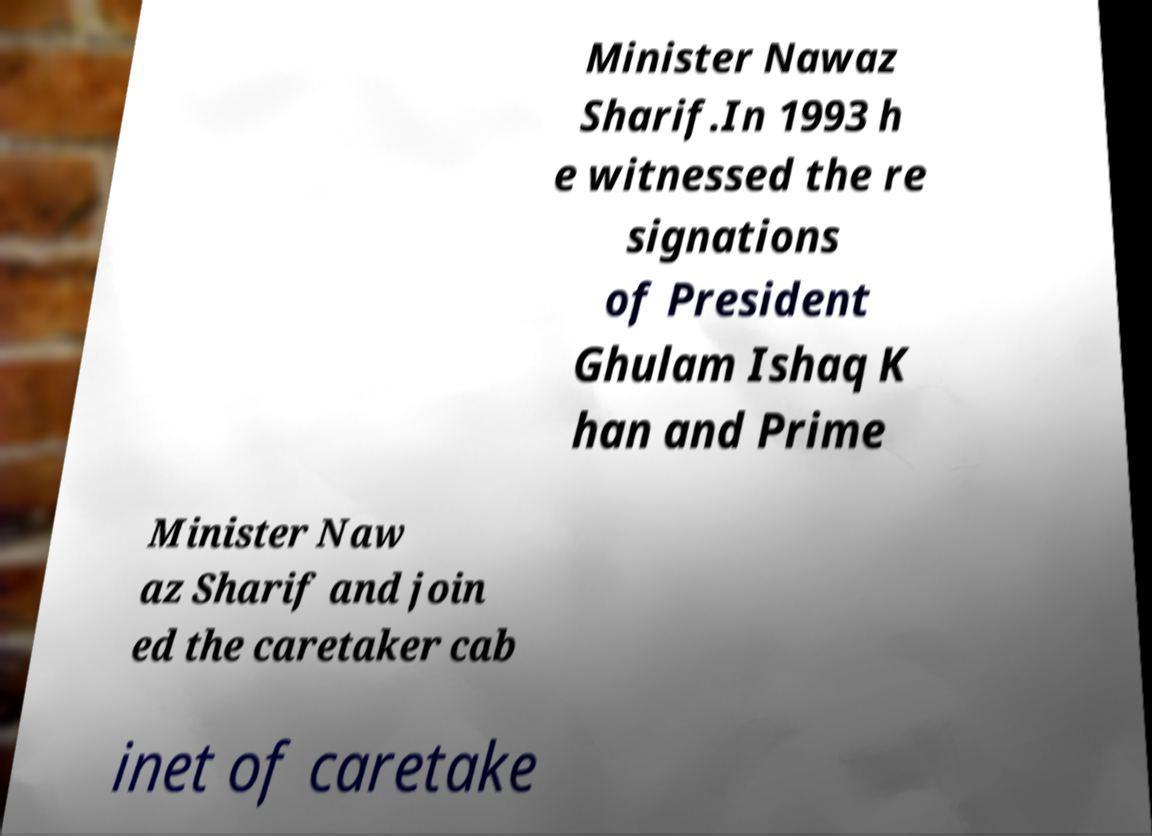What messages or text are displayed in this image? I need them in a readable, typed format. Minister Nawaz Sharif.In 1993 h e witnessed the re signations of President Ghulam Ishaq K han and Prime Minister Naw az Sharif and join ed the caretaker cab inet of caretake 